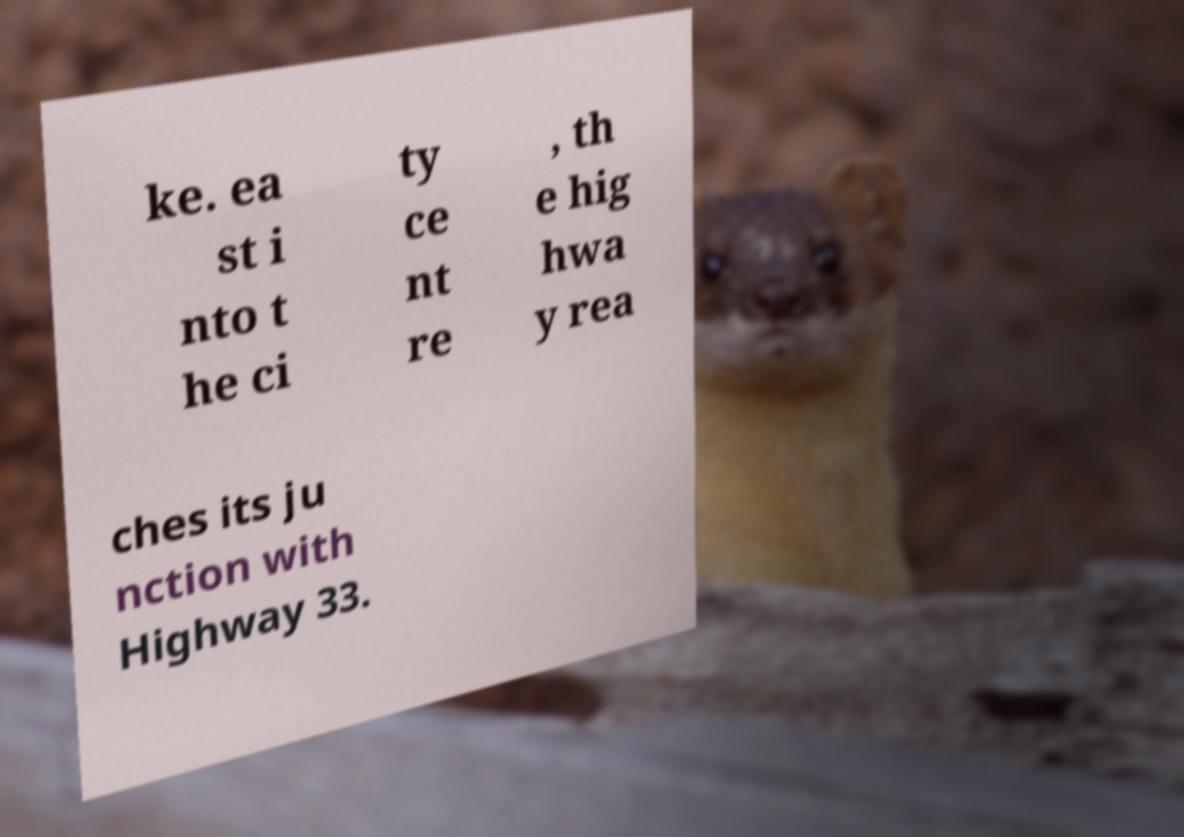What messages or text are displayed in this image? I need them in a readable, typed format. ke. ea st i nto t he ci ty ce nt re , th e hig hwa y rea ches its ju nction with Highway 33. 